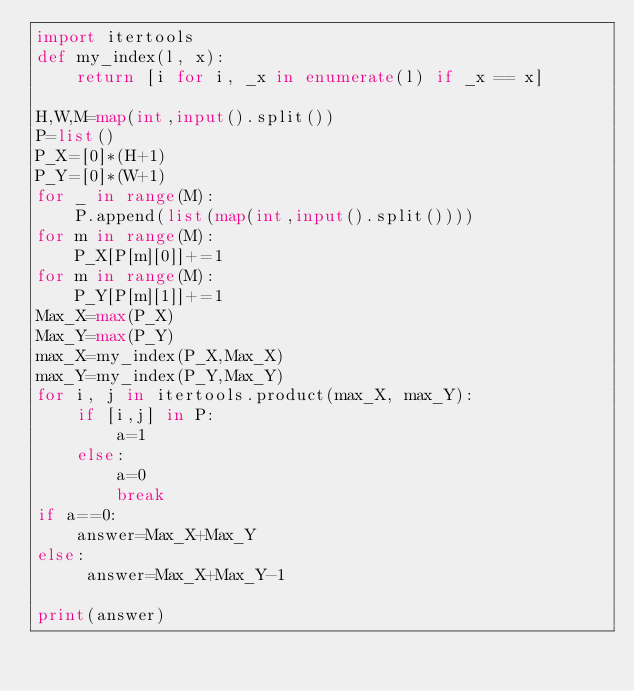<code> <loc_0><loc_0><loc_500><loc_500><_Python_>import itertools
def my_index(l, x):
    return [i for i, _x in enumerate(l) if _x == x]

H,W,M=map(int,input().split())
P=list()
P_X=[0]*(H+1)
P_Y=[0]*(W+1)
for _ in range(M):
    P.append(list(map(int,input().split())))
for m in range(M):
    P_X[P[m][0]]+=1
for m in range(M):
    P_Y[P[m][1]]+=1
Max_X=max(P_X)
Max_Y=max(P_Y)
max_X=my_index(P_X,Max_X)
max_Y=my_index(P_Y,Max_Y)
for i, j in itertools.product(max_X, max_Y):
    if [i,j] in P:
        a=1
    else:
        a=0
        break
if a==0:
    answer=Max_X+Max_Y
else:
     answer=Max_X+Max_Y-1
    
print(answer)

    
</code> 